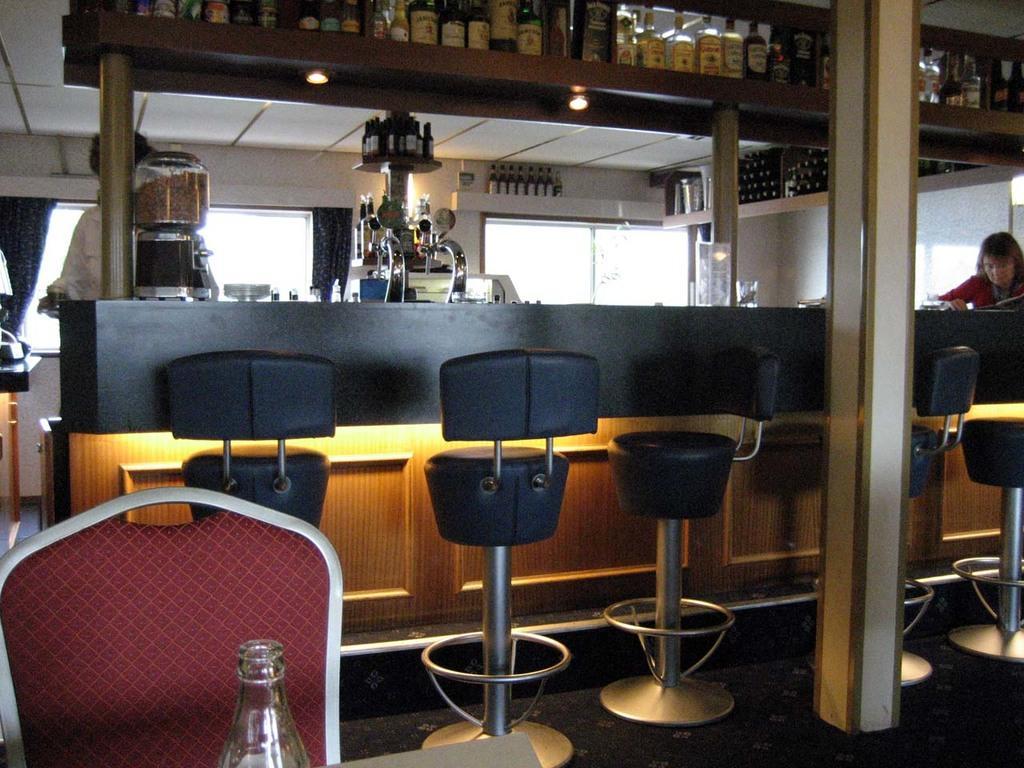How would you summarize this image in a sentence or two? In this picture we can see windows. A man and a woman near to the platform. This is a machine. We can see bottles arranged in a sequence manner at the top. On the floor we can see chairs. This is a bottle in front portion of the picture. 